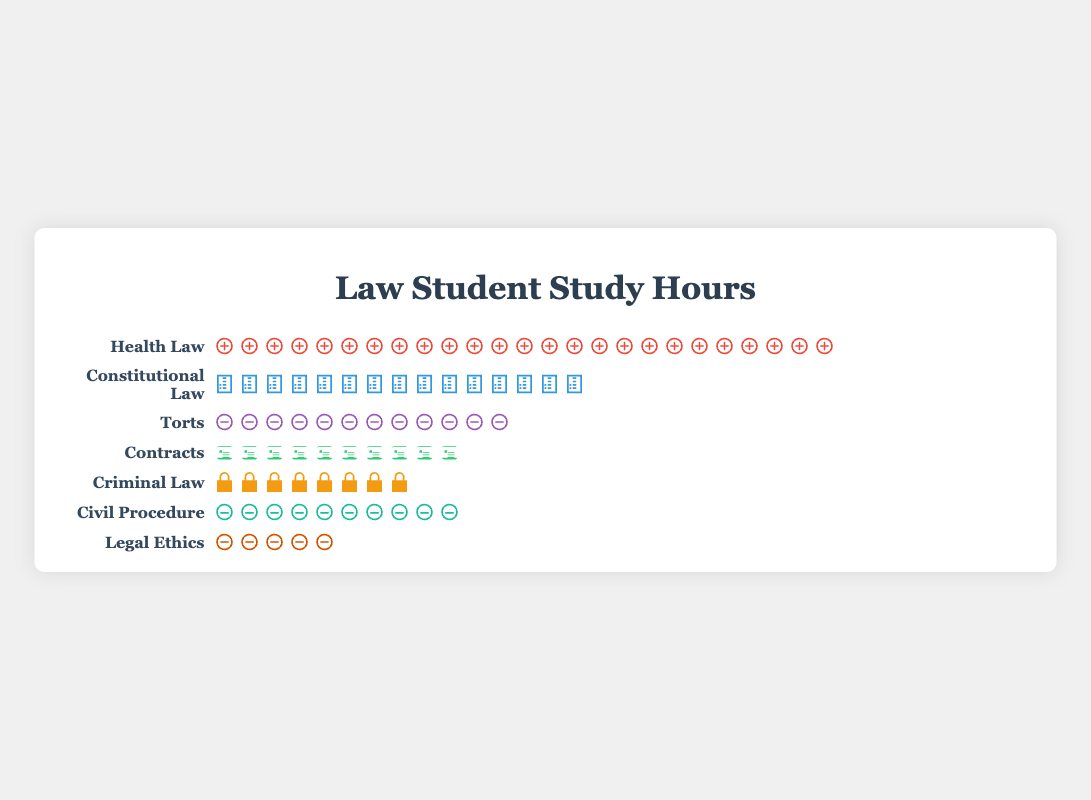How many hours in total does the average student spend studying Constitutional Law and Torts? The student spends 15 hours on Constitutional Law and 12 hours on Torts. Adding these together: 15 + 12 = 27 hours.
Answer: 27 hours Which subject does the average student spend the most time on? By observing the isotype plot, Health Law has the highest number of icons (representing hours), amounting to 25 hours.
Answer: Health Law How many more hours are spent on Contracts than on Legal Ethics? The student spends 10 hours on Contracts and 5 hours on Legal Ethics. The difference is 10 - 5 = 5 hours.
Answer: 5 hours Arrange the subjects by the number of hours spent from highest to lowest. By counting the number of icons for each subject: Health Law (25), Constitutional Law (15), Torts (12), Contracts (10), Civil Procedure (10), Criminal Law (8), Legal Ethics (5).
Answer: Health Law, Constitutional Law, Torts, Contracts, Civil Procedure, Criminal Law, Legal Ethics What is the total number of study hours spent across all subjects? By adding up the hours for each subject: 25 (Health Law) + 15 (Constitutional Law) + 12 (Torts) + 10 (Contracts) + 8 (Criminal Law) + 10 (Civil Procedure) + 5 (Legal Ethics) = 85 hours.
Answer: 85 hours What percentage of total study hours is spent on Criminal Law? The total study hours is 85 hours. Criminal Law hours are 8. The percentage is (8 / 85) * 100 ≈ 9.41%.
Answer: 9.41% Which two subjects have the same amount of study hours? Both Contracts and Civil Procedure have 10 hours each, as indicated by the count of icons.
Answer: Contracts and Civil Procedure How many subjects have study hours less than 10? By counting the number of subjects with fewer than 10 icons: Criminal Law (8) and Legal Ethics (5), making it a total of 2 subjects.
Answer: 2 subjects What is the average number of study hours per subject? The total number of study hours is 85 across 7 subjects. The average is 85 / 7 ≈ 12.14 hours.
Answer: 12.14 hours What is the combined study time for Civil Procedure and Criminal Law? The student spends 10 hours on Civil Procedure and 8 hours on Criminal Law. Adding these together: 10 + 8 = 18 hours.
Answer: 18 hours 